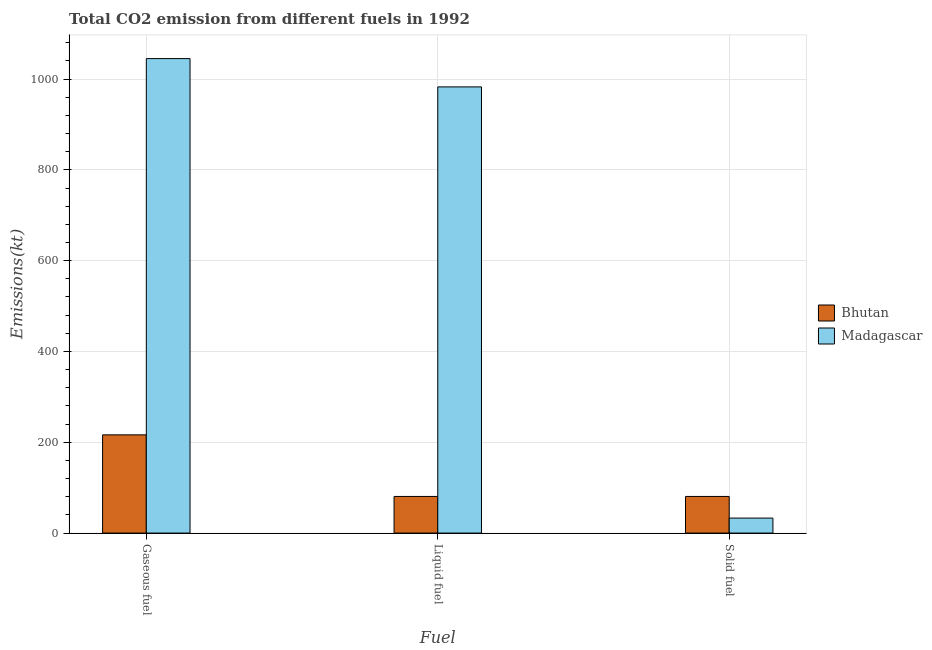How many different coloured bars are there?
Keep it short and to the point. 2. How many groups of bars are there?
Offer a very short reply. 3. What is the label of the 2nd group of bars from the left?
Provide a succinct answer. Liquid fuel. What is the amount of co2 emissions from solid fuel in Madagascar?
Give a very brief answer. 33. Across all countries, what is the maximum amount of co2 emissions from gaseous fuel?
Keep it short and to the point. 1045.1. Across all countries, what is the minimum amount of co2 emissions from gaseous fuel?
Give a very brief answer. 216.35. In which country was the amount of co2 emissions from liquid fuel maximum?
Offer a terse response. Madagascar. In which country was the amount of co2 emissions from liquid fuel minimum?
Make the answer very short. Bhutan. What is the total amount of co2 emissions from liquid fuel in the graph?
Provide a succinct answer. 1063.43. What is the difference between the amount of co2 emissions from gaseous fuel in Madagascar and that in Bhutan?
Your answer should be very brief. 828.74. What is the difference between the amount of co2 emissions from gaseous fuel in Madagascar and the amount of co2 emissions from liquid fuel in Bhutan?
Provide a short and direct response. 964.42. What is the average amount of co2 emissions from liquid fuel per country?
Provide a short and direct response. 531.71. What is the difference between the amount of co2 emissions from gaseous fuel and amount of co2 emissions from liquid fuel in Madagascar?
Make the answer very short. 62.34. In how many countries, is the amount of co2 emissions from gaseous fuel greater than 960 kt?
Keep it short and to the point. 1. What is the ratio of the amount of co2 emissions from gaseous fuel in Madagascar to that in Bhutan?
Your answer should be compact. 4.83. What is the difference between the highest and the second highest amount of co2 emissions from solid fuel?
Provide a succinct answer. 47.67. What is the difference between the highest and the lowest amount of co2 emissions from solid fuel?
Ensure brevity in your answer.  47.67. What does the 1st bar from the left in Liquid fuel represents?
Offer a terse response. Bhutan. What does the 2nd bar from the right in Solid fuel represents?
Offer a terse response. Bhutan. Are all the bars in the graph horizontal?
Your answer should be compact. No. How many countries are there in the graph?
Keep it short and to the point. 2. Does the graph contain any zero values?
Provide a succinct answer. No. Where does the legend appear in the graph?
Provide a succinct answer. Center right. How many legend labels are there?
Provide a short and direct response. 2. How are the legend labels stacked?
Offer a very short reply. Vertical. What is the title of the graph?
Make the answer very short. Total CO2 emission from different fuels in 1992. What is the label or title of the X-axis?
Make the answer very short. Fuel. What is the label or title of the Y-axis?
Offer a terse response. Emissions(kt). What is the Emissions(kt) in Bhutan in Gaseous fuel?
Provide a succinct answer. 216.35. What is the Emissions(kt) of Madagascar in Gaseous fuel?
Make the answer very short. 1045.1. What is the Emissions(kt) in Bhutan in Liquid fuel?
Provide a succinct answer. 80.67. What is the Emissions(kt) in Madagascar in Liquid fuel?
Offer a very short reply. 982.76. What is the Emissions(kt) in Bhutan in Solid fuel?
Offer a very short reply. 80.67. What is the Emissions(kt) in Madagascar in Solid fuel?
Give a very brief answer. 33. Across all Fuel, what is the maximum Emissions(kt) of Bhutan?
Provide a succinct answer. 216.35. Across all Fuel, what is the maximum Emissions(kt) in Madagascar?
Keep it short and to the point. 1045.1. Across all Fuel, what is the minimum Emissions(kt) in Bhutan?
Your answer should be very brief. 80.67. Across all Fuel, what is the minimum Emissions(kt) in Madagascar?
Your response must be concise. 33. What is the total Emissions(kt) of Bhutan in the graph?
Provide a succinct answer. 377.7. What is the total Emissions(kt) of Madagascar in the graph?
Keep it short and to the point. 2060.85. What is the difference between the Emissions(kt) in Bhutan in Gaseous fuel and that in Liquid fuel?
Ensure brevity in your answer.  135.68. What is the difference between the Emissions(kt) in Madagascar in Gaseous fuel and that in Liquid fuel?
Offer a terse response. 62.34. What is the difference between the Emissions(kt) in Bhutan in Gaseous fuel and that in Solid fuel?
Keep it short and to the point. 135.68. What is the difference between the Emissions(kt) of Madagascar in Gaseous fuel and that in Solid fuel?
Make the answer very short. 1012.09. What is the difference between the Emissions(kt) in Bhutan in Liquid fuel and that in Solid fuel?
Your answer should be compact. 0. What is the difference between the Emissions(kt) of Madagascar in Liquid fuel and that in Solid fuel?
Your answer should be compact. 949.75. What is the difference between the Emissions(kt) in Bhutan in Gaseous fuel and the Emissions(kt) in Madagascar in Liquid fuel?
Provide a short and direct response. -766.4. What is the difference between the Emissions(kt) in Bhutan in Gaseous fuel and the Emissions(kt) in Madagascar in Solid fuel?
Keep it short and to the point. 183.35. What is the difference between the Emissions(kt) of Bhutan in Liquid fuel and the Emissions(kt) of Madagascar in Solid fuel?
Give a very brief answer. 47.67. What is the average Emissions(kt) in Bhutan per Fuel?
Provide a succinct answer. 125.9. What is the average Emissions(kt) of Madagascar per Fuel?
Make the answer very short. 686.95. What is the difference between the Emissions(kt) of Bhutan and Emissions(kt) of Madagascar in Gaseous fuel?
Offer a terse response. -828.74. What is the difference between the Emissions(kt) in Bhutan and Emissions(kt) in Madagascar in Liquid fuel?
Offer a very short reply. -902.08. What is the difference between the Emissions(kt) of Bhutan and Emissions(kt) of Madagascar in Solid fuel?
Provide a short and direct response. 47.67. What is the ratio of the Emissions(kt) of Bhutan in Gaseous fuel to that in Liquid fuel?
Provide a short and direct response. 2.68. What is the ratio of the Emissions(kt) of Madagascar in Gaseous fuel to that in Liquid fuel?
Provide a succinct answer. 1.06. What is the ratio of the Emissions(kt) in Bhutan in Gaseous fuel to that in Solid fuel?
Keep it short and to the point. 2.68. What is the ratio of the Emissions(kt) in Madagascar in Gaseous fuel to that in Solid fuel?
Keep it short and to the point. 31.67. What is the ratio of the Emissions(kt) in Bhutan in Liquid fuel to that in Solid fuel?
Make the answer very short. 1. What is the ratio of the Emissions(kt) of Madagascar in Liquid fuel to that in Solid fuel?
Your answer should be compact. 29.78. What is the difference between the highest and the second highest Emissions(kt) of Bhutan?
Provide a succinct answer. 135.68. What is the difference between the highest and the second highest Emissions(kt) of Madagascar?
Provide a short and direct response. 62.34. What is the difference between the highest and the lowest Emissions(kt) of Bhutan?
Offer a terse response. 135.68. What is the difference between the highest and the lowest Emissions(kt) of Madagascar?
Provide a succinct answer. 1012.09. 